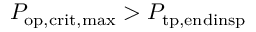<formula> <loc_0><loc_0><loc_500><loc_500>P _ { o p , c r i t , \max } > P _ { t p , e n d i n s p }</formula> 